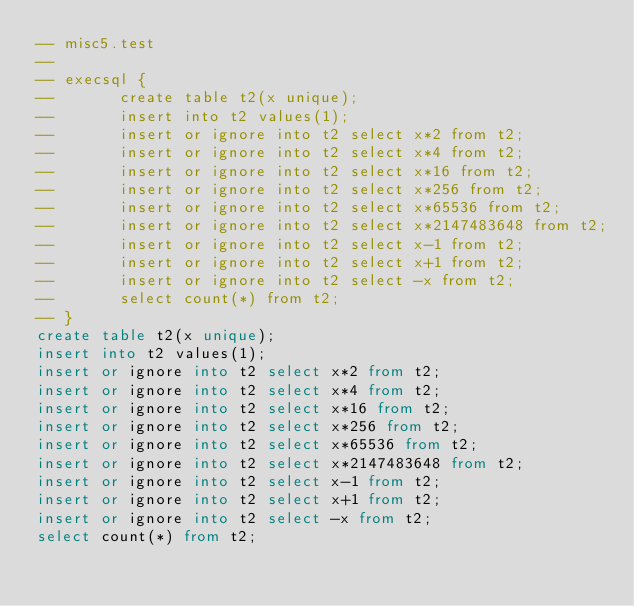<code> <loc_0><loc_0><loc_500><loc_500><_SQL_>-- misc5.test
-- 
-- execsql {
--       create table t2(x unique);
--       insert into t2 values(1);
--       insert or ignore into t2 select x*2 from t2;
--       insert or ignore into t2 select x*4 from t2;
--       insert or ignore into t2 select x*16 from t2;
--       insert or ignore into t2 select x*256 from t2;
--       insert or ignore into t2 select x*65536 from t2;
--       insert or ignore into t2 select x*2147483648 from t2;
--       insert or ignore into t2 select x-1 from t2;
--       insert or ignore into t2 select x+1 from t2;
--       insert or ignore into t2 select -x from t2;
--       select count(*) from t2;
-- }
create table t2(x unique);
insert into t2 values(1);
insert or ignore into t2 select x*2 from t2;
insert or ignore into t2 select x*4 from t2;
insert or ignore into t2 select x*16 from t2;
insert or ignore into t2 select x*256 from t2;
insert or ignore into t2 select x*65536 from t2;
insert or ignore into t2 select x*2147483648 from t2;
insert or ignore into t2 select x-1 from t2;
insert or ignore into t2 select x+1 from t2;
insert or ignore into t2 select -x from t2;
select count(*) from t2;</code> 